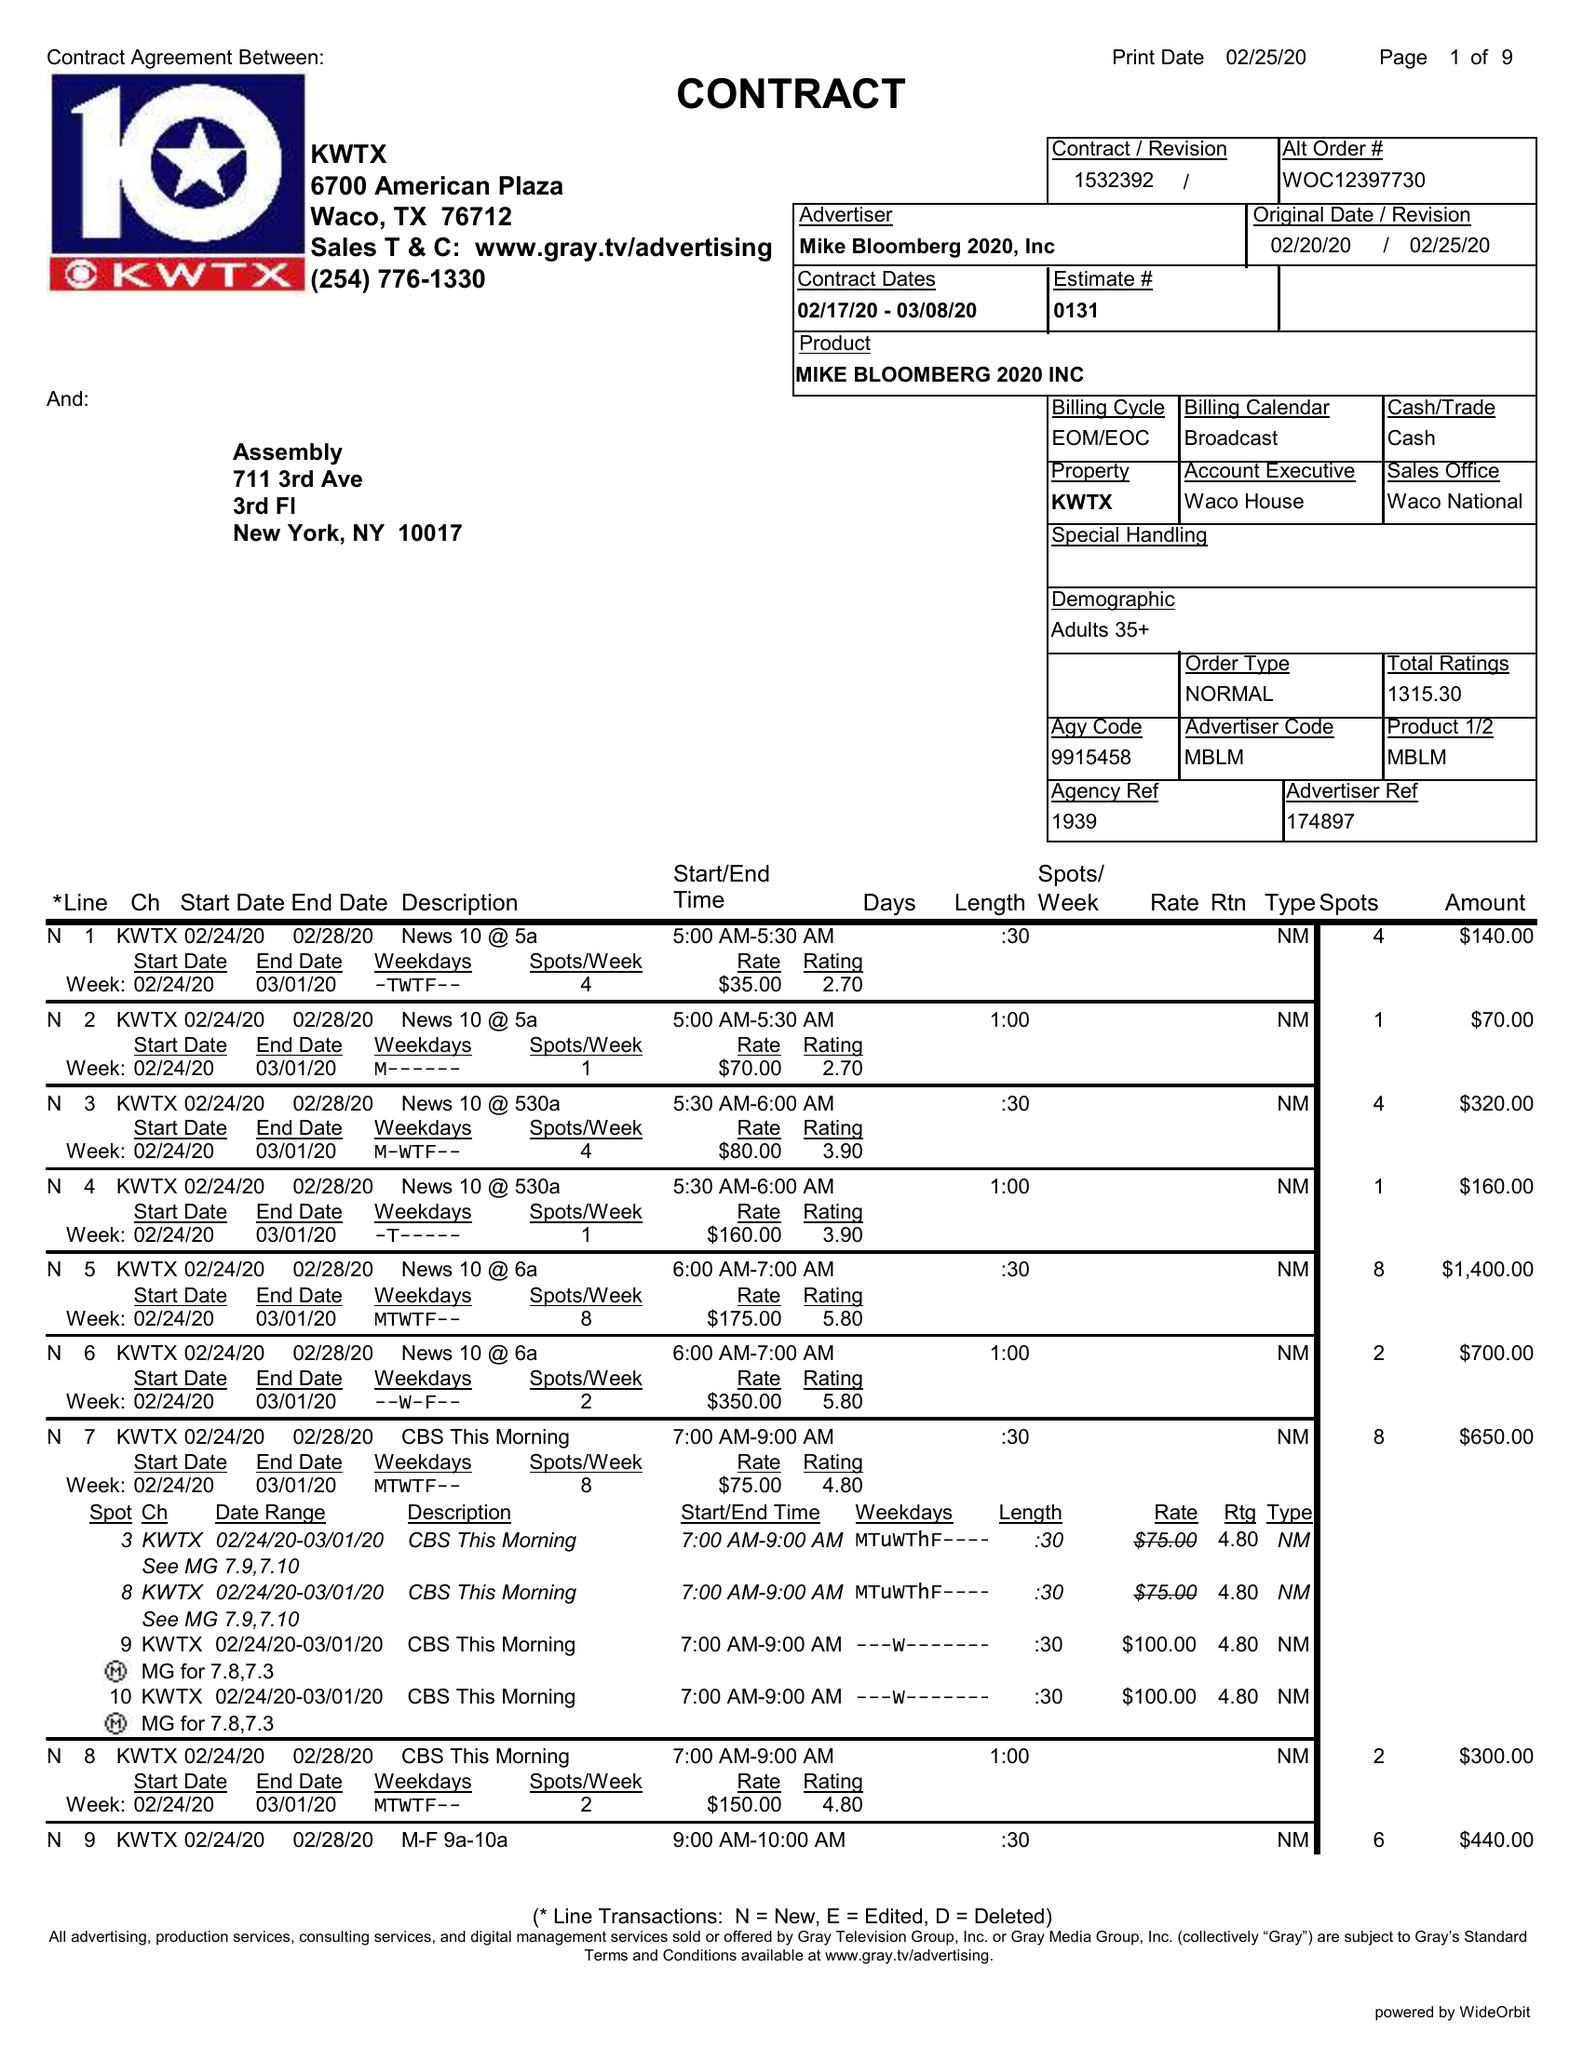What is the value for the flight_to?
Answer the question using a single word or phrase. 03/08/20 